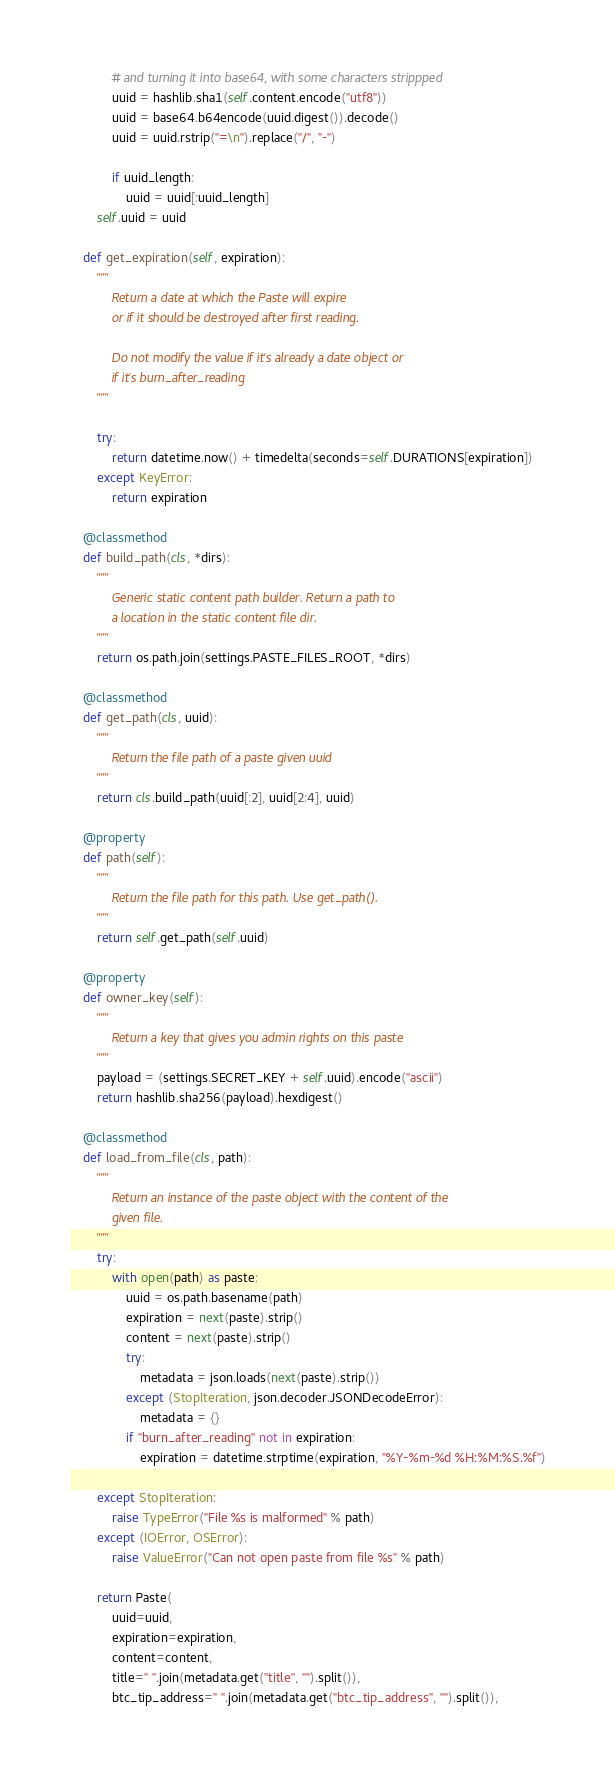<code> <loc_0><loc_0><loc_500><loc_500><_Python_>            # and turning it into base64, with some characters strippped
            uuid = hashlib.sha1(self.content.encode("utf8"))
            uuid = base64.b64encode(uuid.digest()).decode()
            uuid = uuid.rstrip("=\n").replace("/", "-")

            if uuid_length:
                uuid = uuid[:uuid_length]
        self.uuid = uuid

    def get_expiration(self, expiration):
        """
            Return a date at which the Paste will expire
            or if it should be destroyed after first reading.

            Do not modify the value if it's already a date object or
            if it's burn_after_reading
        """

        try:
            return datetime.now() + timedelta(seconds=self.DURATIONS[expiration])
        except KeyError:
            return expiration

    @classmethod
    def build_path(cls, *dirs):
        """
            Generic static content path builder. Return a path to
            a location in the static content file dir.
        """
        return os.path.join(settings.PASTE_FILES_ROOT, *dirs)

    @classmethod
    def get_path(cls, uuid):
        """
            Return the file path of a paste given uuid
        """
        return cls.build_path(uuid[:2], uuid[2:4], uuid)

    @property
    def path(self):
        """
            Return the file path for this path. Use get_path().
        """
        return self.get_path(self.uuid)

    @property
    def owner_key(self):
        """
            Return a key that gives you admin rights on this paste
        """
        payload = (settings.SECRET_KEY + self.uuid).encode("ascii")
        return hashlib.sha256(payload).hexdigest()

    @classmethod
    def load_from_file(cls, path):
        """
            Return an instance of the paste object with the content of the
            given file.
        """
        try:
            with open(path) as paste:
                uuid = os.path.basename(path)
                expiration = next(paste).strip()
                content = next(paste).strip()
                try:
                    metadata = json.loads(next(paste).strip())
                except (StopIteration, json.decoder.JSONDecodeError):
                    metadata = {}
                if "burn_after_reading" not in expiration:
                    expiration = datetime.strptime(expiration, "%Y-%m-%d %H:%M:%S.%f")

        except StopIteration:
            raise TypeError("File %s is malformed" % path)
        except (IOError, OSError):
            raise ValueError("Can not open paste from file %s" % path)

        return Paste(
            uuid=uuid,
            expiration=expiration,
            content=content,
            title=" ".join(metadata.get("title", "").split()),
            btc_tip_address=" ".join(metadata.get("btc_tip_address", "").split()),</code> 